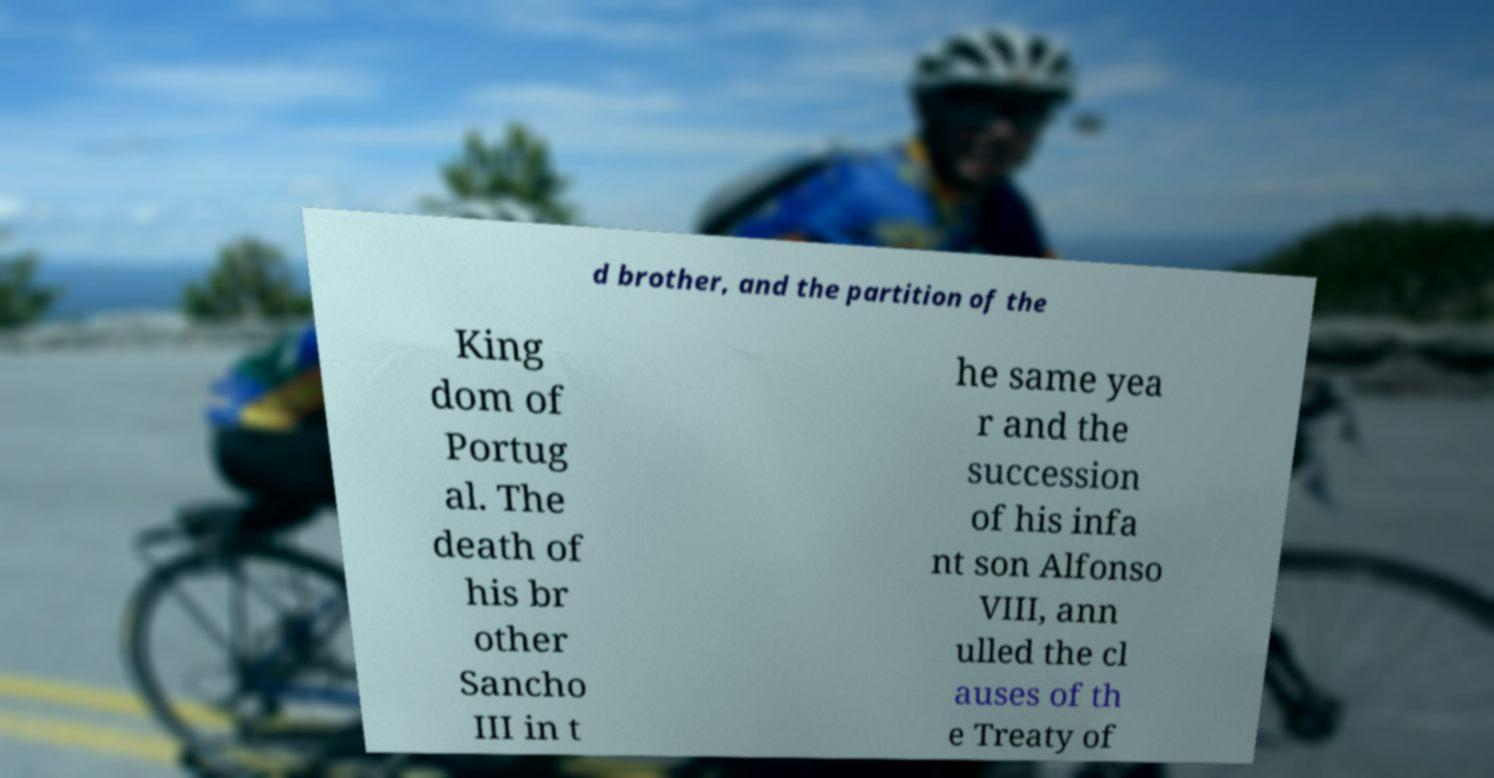I need the written content from this picture converted into text. Can you do that? d brother, and the partition of the King dom of Portug al. The death of his br other Sancho III in t he same yea r and the succession of his infa nt son Alfonso VIII, ann ulled the cl auses of th e Treaty of 